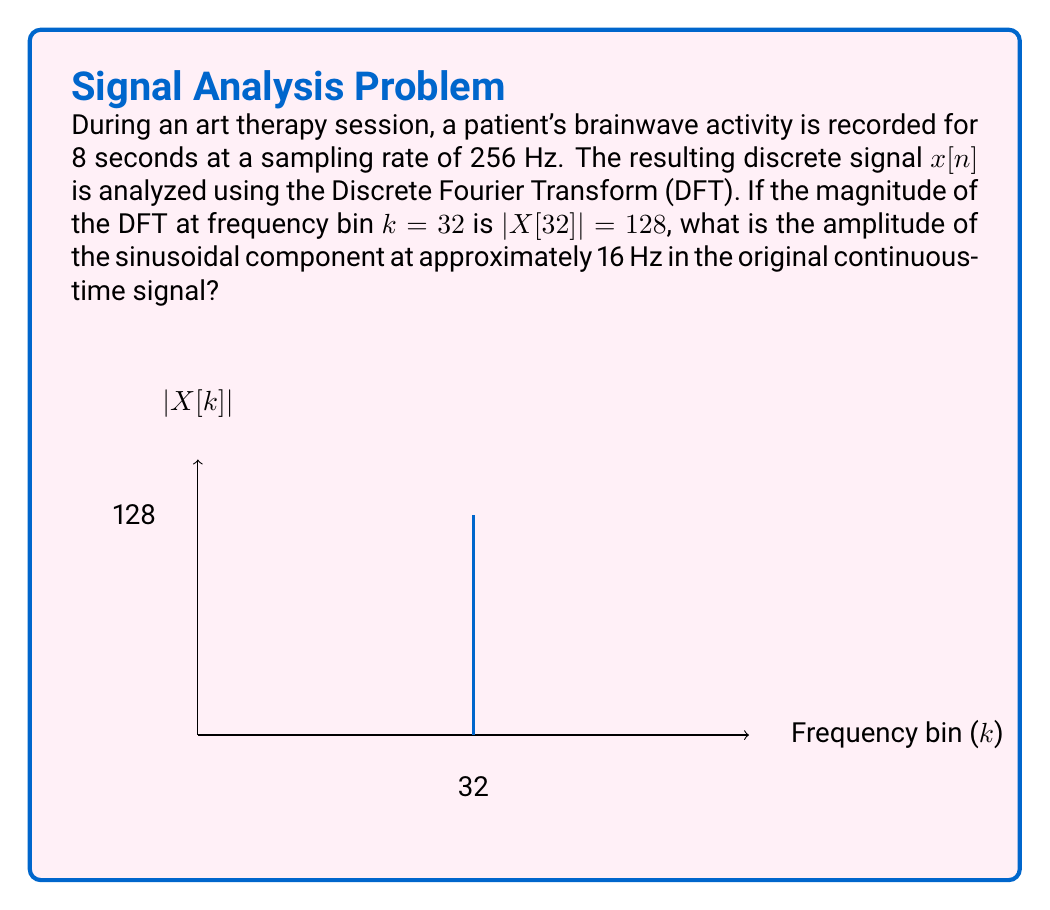Can you answer this question? Let's approach this step-by-step:

1) First, we need to understand the relationship between the DFT bin number and the actual frequency:

   $f = k \cdot \frac{f_s}{N}$

   Where $f$ is the frequency, $k$ is the bin number, $f_s$ is the sampling rate, and $N$ is the total number of samples.

2) We're given:
   - Sampling rate $f_s = 256$ Hz
   - Recording duration = 8 seconds
   - $k = 32$
   - $|X[32]| = 128$

3) Calculate $N$:
   $N = f_s \cdot \text{duration} = 256 \cdot 8 = 2048$ samples

4) Verify the frequency:
   $f = 32 \cdot \frac{256}{2048} = 16$ Hz

5) Now, we need to relate the DFT magnitude to the amplitude of the sinusoidal component. For a real-valued signal, the relationship is:

   $A = \frac{2|X[k]|}{N}$

   Where $A$ is the amplitude of the sinusoidal component.

6) Substituting our values:

   $A = \frac{2 \cdot 128}{2048} = \frac{256}{2048} = \frac{1}{8} = 0.125$

Therefore, the amplitude of the 16 Hz component in the original continuous-time signal is 0.125.
Answer: 0.125 